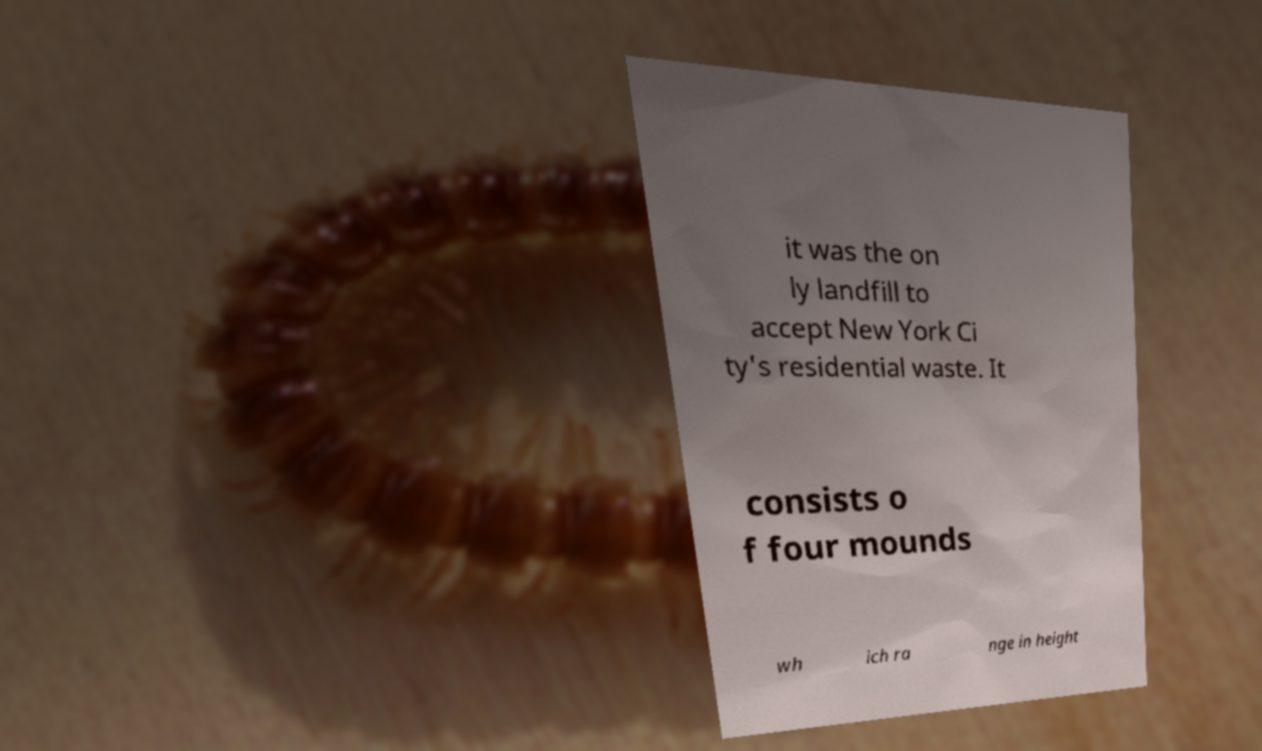Can you read and provide the text displayed in the image?This photo seems to have some interesting text. Can you extract and type it out for me? it was the on ly landfill to accept New York Ci ty's residential waste. It consists o f four mounds wh ich ra nge in height 